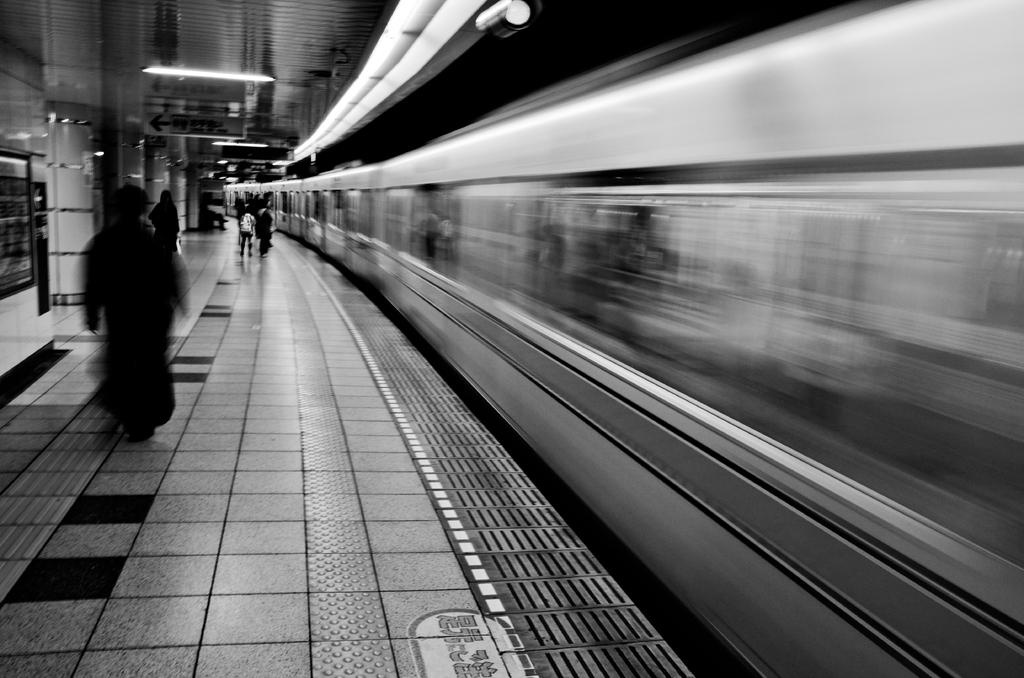What is the main subject of the image? The main subject of the image is a train. What is located beside the train? There is a platform beside the train. Can you describe the people visible in the image? There are people visible in the image, but their specific actions or roles are not mentioned. What type of illumination is present in the image? Lights are present in the image. What architectural features can be seen in the image? Pillars are visible in the image. What other unspecified objects are present in the image? There are some unspecified objects in the image, but their nature or purpose is not mentioned. How many feet are visible on the governor in the image? There is no governor present in the image, and therefore no feet to count. What type of vehicle is the governor driving in the image? There is no governor or vehicle present in the image. 